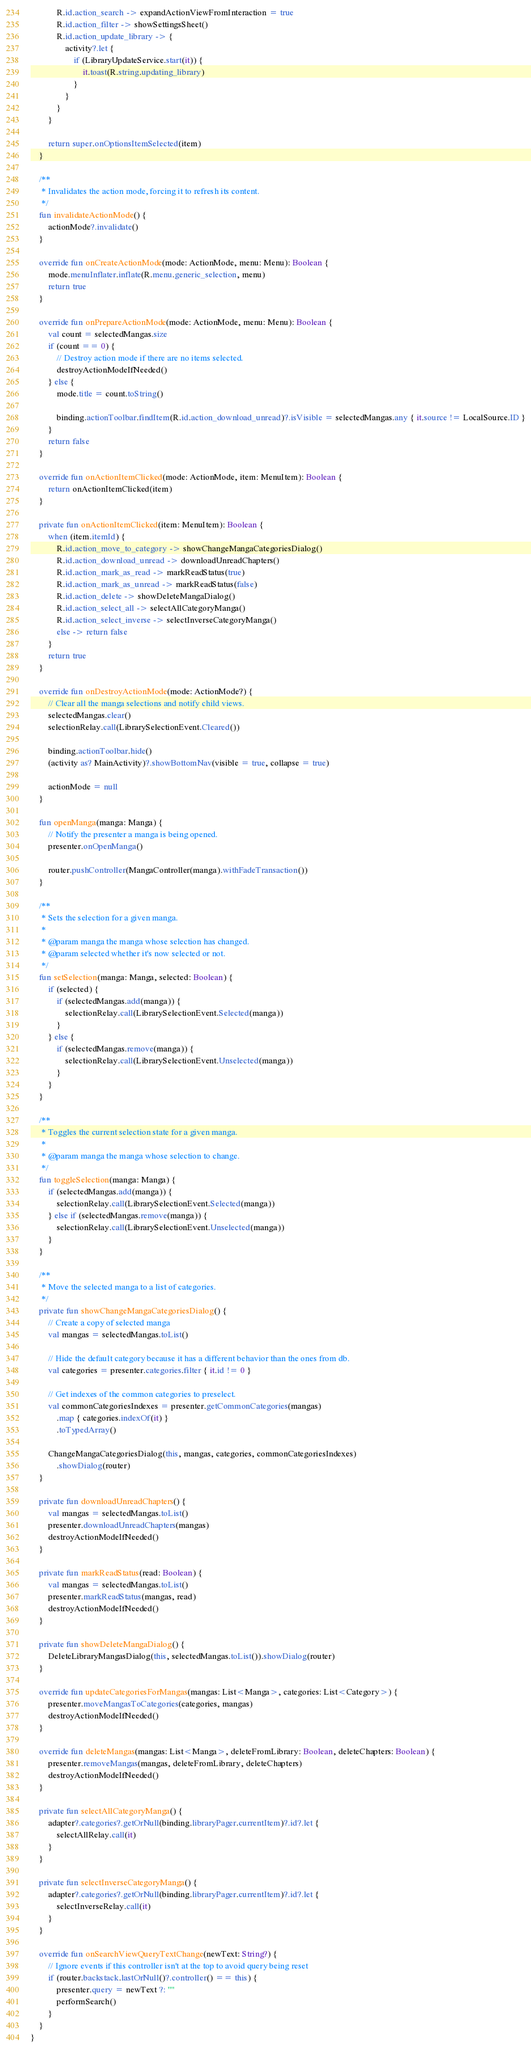<code> <loc_0><loc_0><loc_500><loc_500><_Kotlin_>            R.id.action_search -> expandActionViewFromInteraction = true
            R.id.action_filter -> showSettingsSheet()
            R.id.action_update_library -> {
                activity?.let {
                    if (LibraryUpdateService.start(it)) {
                        it.toast(R.string.updating_library)
                    }
                }
            }
        }

        return super.onOptionsItemSelected(item)
    }

    /**
     * Invalidates the action mode, forcing it to refresh its content.
     */
    fun invalidateActionMode() {
        actionMode?.invalidate()
    }

    override fun onCreateActionMode(mode: ActionMode, menu: Menu): Boolean {
        mode.menuInflater.inflate(R.menu.generic_selection, menu)
        return true
    }

    override fun onPrepareActionMode(mode: ActionMode, menu: Menu): Boolean {
        val count = selectedMangas.size
        if (count == 0) {
            // Destroy action mode if there are no items selected.
            destroyActionModeIfNeeded()
        } else {
            mode.title = count.toString()

            binding.actionToolbar.findItem(R.id.action_download_unread)?.isVisible = selectedMangas.any { it.source != LocalSource.ID }
        }
        return false
    }

    override fun onActionItemClicked(mode: ActionMode, item: MenuItem): Boolean {
        return onActionItemClicked(item)
    }

    private fun onActionItemClicked(item: MenuItem): Boolean {
        when (item.itemId) {
            R.id.action_move_to_category -> showChangeMangaCategoriesDialog()
            R.id.action_download_unread -> downloadUnreadChapters()
            R.id.action_mark_as_read -> markReadStatus(true)
            R.id.action_mark_as_unread -> markReadStatus(false)
            R.id.action_delete -> showDeleteMangaDialog()
            R.id.action_select_all -> selectAllCategoryManga()
            R.id.action_select_inverse -> selectInverseCategoryManga()
            else -> return false
        }
        return true
    }

    override fun onDestroyActionMode(mode: ActionMode?) {
        // Clear all the manga selections and notify child views.
        selectedMangas.clear()
        selectionRelay.call(LibrarySelectionEvent.Cleared())

        binding.actionToolbar.hide()
        (activity as? MainActivity)?.showBottomNav(visible = true, collapse = true)

        actionMode = null
    }

    fun openManga(manga: Manga) {
        // Notify the presenter a manga is being opened.
        presenter.onOpenManga()

        router.pushController(MangaController(manga).withFadeTransaction())
    }

    /**
     * Sets the selection for a given manga.
     *
     * @param manga the manga whose selection has changed.
     * @param selected whether it's now selected or not.
     */
    fun setSelection(manga: Manga, selected: Boolean) {
        if (selected) {
            if (selectedMangas.add(manga)) {
                selectionRelay.call(LibrarySelectionEvent.Selected(manga))
            }
        } else {
            if (selectedMangas.remove(manga)) {
                selectionRelay.call(LibrarySelectionEvent.Unselected(manga))
            }
        }
    }

    /**
     * Toggles the current selection state for a given manga.
     *
     * @param manga the manga whose selection to change.
     */
    fun toggleSelection(manga: Manga) {
        if (selectedMangas.add(manga)) {
            selectionRelay.call(LibrarySelectionEvent.Selected(manga))
        } else if (selectedMangas.remove(manga)) {
            selectionRelay.call(LibrarySelectionEvent.Unselected(manga))
        }
    }

    /**
     * Move the selected manga to a list of categories.
     */
    private fun showChangeMangaCategoriesDialog() {
        // Create a copy of selected manga
        val mangas = selectedMangas.toList()

        // Hide the default category because it has a different behavior than the ones from db.
        val categories = presenter.categories.filter { it.id != 0 }

        // Get indexes of the common categories to preselect.
        val commonCategoriesIndexes = presenter.getCommonCategories(mangas)
            .map { categories.indexOf(it) }
            .toTypedArray()

        ChangeMangaCategoriesDialog(this, mangas, categories, commonCategoriesIndexes)
            .showDialog(router)
    }

    private fun downloadUnreadChapters() {
        val mangas = selectedMangas.toList()
        presenter.downloadUnreadChapters(mangas)
        destroyActionModeIfNeeded()
    }

    private fun markReadStatus(read: Boolean) {
        val mangas = selectedMangas.toList()
        presenter.markReadStatus(mangas, read)
        destroyActionModeIfNeeded()
    }

    private fun showDeleteMangaDialog() {
        DeleteLibraryMangasDialog(this, selectedMangas.toList()).showDialog(router)
    }

    override fun updateCategoriesForMangas(mangas: List<Manga>, categories: List<Category>) {
        presenter.moveMangasToCategories(categories, mangas)
        destroyActionModeIfNeeded()
    }

    override fun deleteMangas(mangas: List<Manga>, deleteFromLibrary: Boolean, deleteChapters: Boolean) {
        presenter.removeMangas(mangas, deleteFromLibrary, deleteChapters)
        destroyActionModeIfNeeded()
    }

    private fun selectAllCategoryManga() {
        adapter?.categories?.getOrNull(binding.libraryPager.currentItem)?.id?.let {
            selectAllRelay.call(it)
        }
    }

    private fun selectInverseCategoryManga() {
        adapter?.categories?.getOrNull(binding.libraryPager.currentItem)?.id?.let {
            selectInverseRelay.call(it)
        }
    }

    override fun onSearchViewQueryTextChange(newText: String?) {
        // Ignore events if this controller isn't at the top to avoid query being reset
        if (router.backstack.lastOrNull()?.controller() == this) {
            presenter.query = newText ?: ""
            performSearch()
        }
    }
}
</code> 